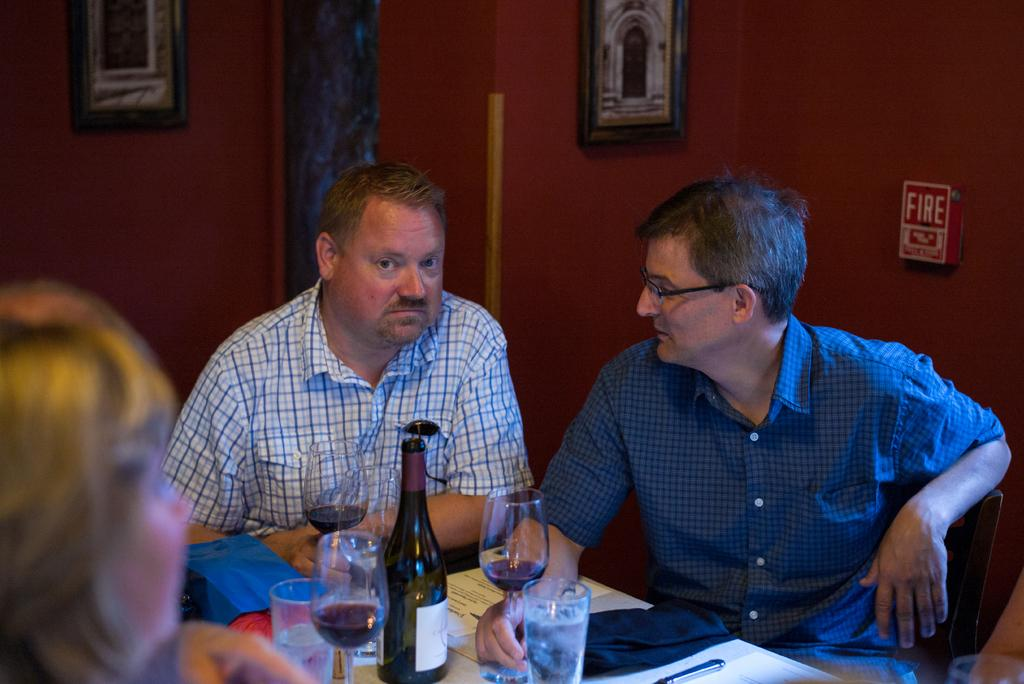What are the people in the image doing? The people in the image are sitting on chairs. What can be seen on the table in the image? There is a red wine bottle on the table. What is in the wine glass in the image? The wine glass contains red wine. What type of gun is present in the image? There is no gun present in the image. What disease is being treated in the image? There is no indication of a disease or treatment in the image. 